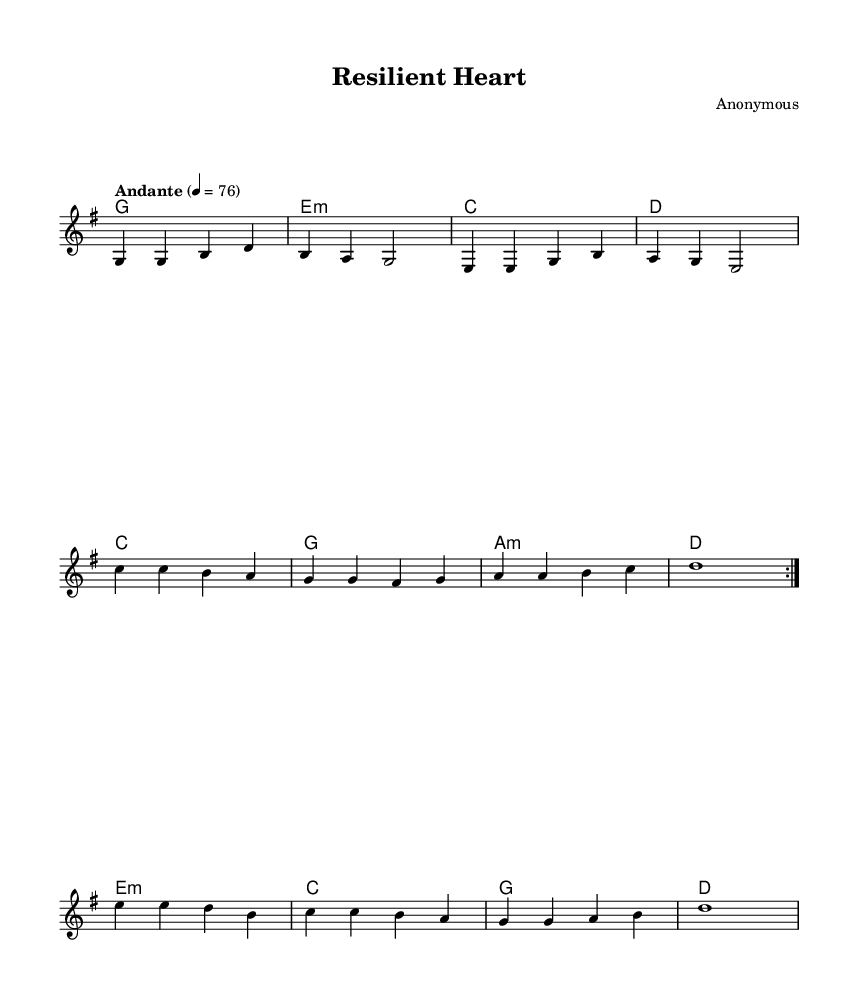What is the key signature of this music? The key signature is G major, which has one sharp (F#). This can be determined by looking at the clef and the key signature on the left side of the staff.
Answer: G major What is the time signature of this music? The time signature is 4/4, indicating that there are four beats per measure and the quarter note gets one beat. This is shown at the beginning of the piece.
Answer: 4/4 What is the tempo marking for this piece? The tempo marking is "Andante," which suggests a moderate pace. This is noted at the beginning where the tempo is indicated.
Answer: Andante How many measures are there in the verse? There are four measures in the verse. Counting the vertical lines separating the measures in the verse section confirms this.
Answer: Four What is the first note of the chorus? The first note of the chorus is C. This is identified by the note represented at the beginning of the chorus line in the music.
Answer: C Which section follows the second chorus? The bridge follows the second chorus. This can be identified by the structure of the song shown in the score. After the repeated chorus, the next section is labeled as the bridge.
Answer: Bridge What lyrical theme is presented in the bridge? The theme presented in the bridge is discovery of self-worth, as indicated by the lyrics included in that section. This examination of the lyrics reveals the focus on resilience and personal strength.
Answer: Self-worth 